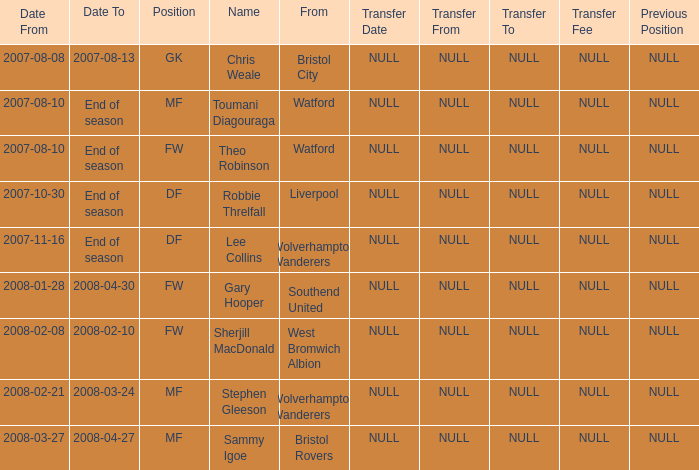Where was the player from who had the position of DF, who started 2007-10-30? Liverpool. Could you parse the entire table? {'header': ['Date From', 'Date To', 'Position', 'Name', 'From', 'Transfer Date', 'Transfer From', 'Transfer To', 'Transfer Fee', 'Previous Position'], 'rows': [['2007-08-08', '2007-08-13', 'GK', 'Chris Weale', 'Bristol City', 'NULL', 'NULL', 'NULL', 'NULL', 'NULL'], ['2007-08-10', 'End of season', 'MF', 'Toumani Diagouraga', 'Watford', 'NULL', 'NULL', 'NULL', 'NULL', 'NULL'], ['2007-08-10', 'End of season', 'FW', 'Theo Robinson', 'Watford', 'NULL', 'NULL', 'NULL', 'NULL', 'NULL'], ['2007-10-30', 'End of season', 'DF', 'Robbie Threlfall', 'Liverpool', 'NULL', 'NULL', 'NULL', 'NULL', 'NULL'], ['2007-11-16', 'End of season', 'DF', 'Lee Collins', 'Wolverhampton Wanderers', 'NULL', 'NULL', 'NULL', 'NULL', 'NULL'], ['2008-01-28', '2008-04-30', 'FW', 'Gary Hooper', 'Southend United', 'NULL', 'NULL', 'NULL', 'NULL', 'NULL'], ['2008-02-08', '2008-02-10', 'FW', 'Sherjill MacDonald', 'West Bromwich Albion', 'NULL', 'NULL', 'NULL', 'NULL', 'NULL'], ['2008-02-21', '2008-03-24', 'MF', 'Stephen Gleeson', 'Wolverhampton Wanderers', 'NULL', 'NULL', 'NULL', 'NULL', 'NULL'], ['2008-03-27', '2008-04-27', 'MF', 'Sammy Igoe', 'Bristol Rovers', 'NULL', 'NULL', 'NULL', 'NULL', 'NULL']]} 